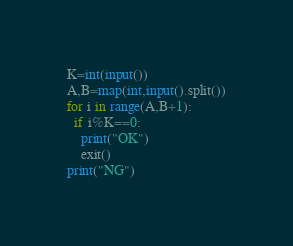Convert code to text. <code><loc_0><loc_0><loc_500><loc_500><_Python_>K=int(input())
A,B=map(int,input().split())
for i in range(A,B+1):
  if i%K==0:
    print("OK")
    exit()
print("NG")</code> 